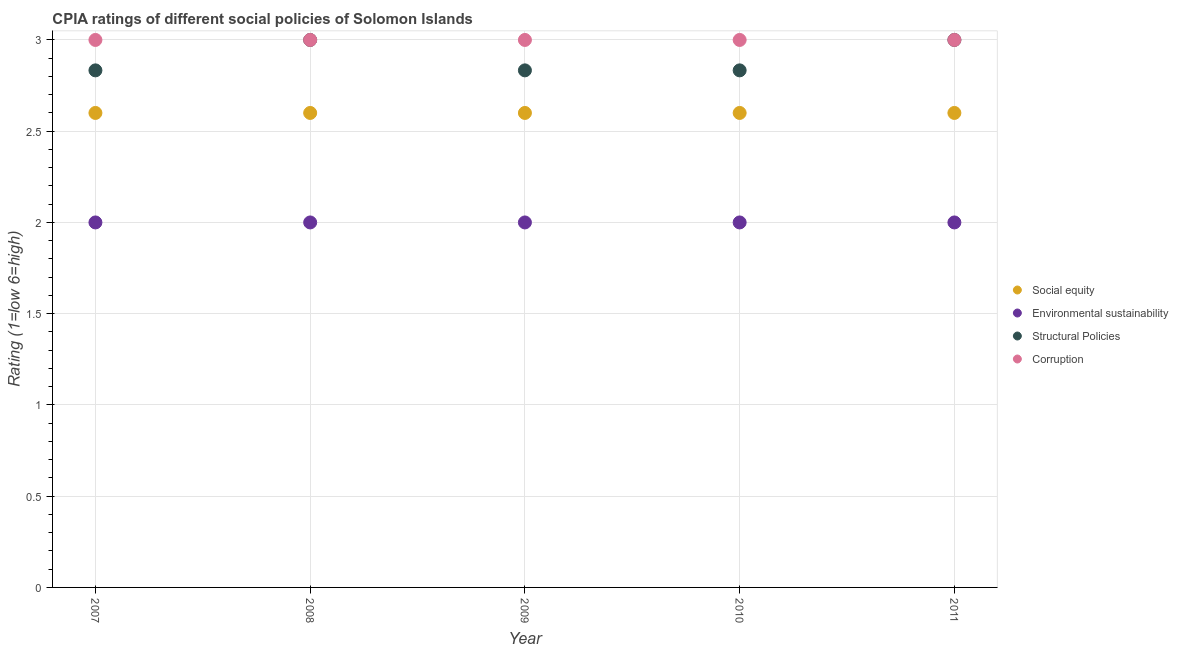What is the cpia rating of social equity in 2008?
Give a very brief answer. 2.6. Across all years, what is the maximum cpia rating of social equity?
Offer a terse response. 2.6. Across all years, what is the minimum cpia rating of corruption?
Keep it short and to the point. 3. In which year was the cpia rating of corruption maximum?
Provide a short and direct response. 2007. What is the total cpia rating of social equity in the graph?
Make the answer very short. 13. What is the difference between the cpia rating of environmental sustainability in 2008 and that in 2009?
Keep it short and to the point. 0. What is the difference between the cpia rating of structural policies in 2011 and the cpia rating of social equity in 2007?
Offer a very short reply. 0.4. In how many years, is the cpia rating of corruption greater than 1.6?
Your response must be concise. 5. What is the ratio of the cpia rating of corruption in 2009 to that in 2011?
Provide a short and direct response. 1. Is the difference between the cpia rating of environmental sustainability in 2007 and 2011 greater than the difference between the cpia rating of social equity in 2007 and 2011?
Keep it short and to the point. No. What is the difference between the highest and the lowest cpia rating of social equity?
Offer a terse response. 0. Is the sum of the cpia rating of environmental sustainability in 2008 and 2009 greater than the maximum cpia rating of social equity across all years?
Give a very brief answer. Yes. Does the cpia rating of structural policies monotonically increase over the years?
Your response must be concise. No. Is the cpia rating of social equity strictly greater than the cpia rating of environmental sustainability over the years?
Make the answer very short. Yes. Is the cpia rating of structural policies strictly less than the cpia rating of environmental sustainability over the years?
Provide a short and direct response. No. How many dotlines are there?
Your response must be concise. 4. Does the graph contain any zero values?
Make the answer very short. No. What is the title of the graph?
Offer a terse response. CPIA ratings of different social policies of Solomon Islands. Does "Austria" appear as one of the legend labels in the graph?
Ensure brevity in your answer.  No. What is the label or title of the Y-axis?
Provide a succinct answer. Rating (1=low 6=high). What is the Rating (1=low 6=high) of Environmental sustainability in 2007?
Give a very brief answer. 2. What is the Rating (1=low 6=high) in Structural Policies in 2007?
Provide a short and direct response. 2.83. What is the Rating (1=low 6=high) in Corruption in 2007?
Keep it short and to the point. 3. What is the Rating (1=low 6=high) in Structural Policies in 2008?
Your answer should be very brief. 3. What is the Rating (1=low 6=high) in Corruption in 2008?
Offer a very short reply. 3. What is the Rating (1=low 6=high) in Structural Policies in 2009?
Offer a terse response. 2.83. What is the Rating (1=low 6=high) in Social equity in 2010?
Provide a succinct answer. 2.6. What is the Rating (1=low 6=high) in Environmental sustainability in 2010?
Your response must be concise. 2. What is the Rating (1=low 6=high) of Structural Policies in 2010?
Your answer should be very brief. 2.83. What is the Rating (1=low 6=high) in Corruption in 2010?
Keep it short and to the point. 3. What is the Rating (1=low 6=high) in Social equity in 2011?
Keep it short and to the point. 2.6. What is the Rating (1=low 6=high) in Structural Policies in 2011?
Keep it short and to the point. 3. Across all years, what is the maximum Rating (1=low 6=high) of Social equity?
Your answer should be compact. 2.6. Across all years, what is the maximum Rating (1=low 6=high) in Environmental sustainability?
Make the answer very short. 2. Across all years, what is the maximum Rating (1=low 6=high) of Corruption?
Make the answer very short. 3. Across all years, what is the minimum Rating (1=low 6=high) of Structural Policies?
Ensure brevity in your answer.  2.83. Across all years, what is the minimum Rating (1=low 6=high) in Corruption?
Give a very brief answer. 3. What is the total Rating (1=low 6=high) of Social equity in the graph?
Keep it short and to the point. 13. What is the total Rating (1=low 6=high) of Environmental sustainability in the graph?
Provide a succinct answer. 10. What is the total Rating (1=low 6=high) of Corruption in the graph?
Offer a terse response. 15. What is the difference between the Rating (1=low 6=high) in Environmental sustainability in 2007 and that in 2008?
Offer a very short reply. 0. What is the difference between the Rating (1=low 6=high) of Corruption in 2007 and that in 2008?
Offer a terse response. 0. What is the difference between the Rating (1=low 6=high) in Social equity in 2007 and that in 2009?
Keep it short and to the point. 0. What is the difference between the Rating (1=low 6=high) in Environmental sustainability in 2007 and that in 2009?
Make the answer very short. 0. What is the difference between the Rating (1=low 6=high) in Structural Policies in 2007 and that in 2009?
Your answer should be compact. 0. What is the difference between the Rating (1=low 6=high) in Corruption in 2007 and that in 2009?
Offer a terse response. 0. What is the difference between the Rating (1=low 6=high) in Corruption in 2007 and that in 2010?
Give a very brief answer. 0. What is the difference between the Rating (1=low 6=high) of Structural Policies in 2007 and that in 2011?
Your answer should be very brief. -0.17. What is the difference between the Rating (1=low 6=high) of Social equity in 2008 and that in 2009?
Make the answer very short. 0. What is the difference between the Rating (1=low 6=high) of Environmental sustainability in 2008 and that in 2009?
Ensure brevity in your answer.  0. What is the difference between the Rating (1=low 6=high) of Structural Policies in 2008 and that in 2009?
Provide a succinct answer. 0.17. What is the difference between the Rating (1=low 6=high) in Corruption in 2008 and that in 2009?
Give a very brief answer. 0. What is the difference between the Rating (1=low 6=high) in Social equity in 2008 and that in 2010?
Make the answer very short. 0. What is the difference between the Rating (1=low 6=high) of Environmental sustainability in 2008 and that in 2010?
Provide a succinct answer. 0. What is the difference between the Rating (1=low 6=high) of Structural Policies in 2008 and that in 2010?
Offer a terse response. 0.17. What is the difference between the Rating (1=low 6=high) of Social equity in 2008 and that in 2011?
Make the answer very short. 0. What is the difference between the Rating (1=low 6=high) in Environmental sustainability in 2008 and that in 2011?
Your answer should be compact. 0. What is the difference between the Rating (1=low 6=high) in Corruption in 2008 and that in 2011?
Provide a short and direct response. 0. What is the difference between the Rating (1=low 6=high) in Social equity in 2009 and that in 2010?
Offer a very short reply. 0. What is the difference between the Rating (1=low 6=high) in Social equity in 2009 and that in 2011?
Offer a terse response. 0. What is the difference between the Rating (1=low 6=high) in Structural Policies in 2009 and that in 2011?
Offer a terse response. -0.17. What is the difference between the Rating (1=low 6=high) in Environmental sustainability in 2010 and that in 2011?
Provide a succinct answer. 0. What is the difference between the Rating (1=low 6=high) of Structural Policies in 2010 and that in 2011?
Your answer should be very brief. -0.17. What is the difference between the Rating (1=low 6=high) of Social equity in 2007 and the Rating (1=low 6=high) of Environmental sustainability in 2008?
Give a very brief answer. 0.6. What is the difference between the Rating (1=low 6=high) in Social equity in 2007 and the Rating (1=low 6=high) in Structural Policies in 2008?
Keep it short and to the point. -0.4. What is the difference between the Rating (1=low 6=high) in Environmental sustainability in 2007 and the Rating (1=low 6=high) in Corruption in 2008?
Offer a very short reply. -1. What is the difference between the Rating (1=low 6=high) in Structural Policies in 2007 and the Rating (1=low 6=high) in Corruption in 2008?
Ensure brevity in your answer.  -0.17. What is the difference between the Rating (1=low 6=high) in Social equity in 2007 and the Rating (1=low 6=high) in Environmental sustainability in 2009?
Your response must be concise. 0.6. What is the difference between the Rating (1=low 6=high) of Social equity in 2007 and the Rating (1=low 6=high) of Structural Policies in 2009?
Make the answer very short. -0.23. What is the difference between the Rating (1=low 6=high) of Social equity in 2007 and the Rating (1=low 6=high) of Corruption in 2009?
Your response must be concise. -0.4. What is the difference between the Rating (1=low 6=high) of Environmental sustainability in 2007 and the Rating (1=low 6=high) of Structural Policies in 2009?
Ensure brevity in your answer.  -0.83. What is the difference between the Rating (1=low 6=high) in Social equity in 2007 and the Rating (1=low 6=high) in Structural Policies in 2010?
Give a very brief answer. -0.23. What is the difference between the Rating (1=low 6=high) in Social equity in 2007 and the Rating (1=low 6=high) in Corruption in 2010?
Offer a very short reply. -0.4. What is the difference between the Rating (1=low 6=high) in Environmental sustainability in 2007 and the Rating (1=low 6=high) in Structural Policies in 2010?
Keep it short and to the point. -0.83. What is the difference between the Rating (1=low 6=high) in Environmental sustainability in 2007 and the Rating (1=low 6=high) in Corruption in 2010?
Offer a terse response. -1. What is the difference between the Rating (1=low 6=high) of Structural Policies in 2007 and the Rating (1=low 6=high) of Corruption in 2010?
Make the answer very short. -0.17. What is the difference between the Rating (1=low 6=high) in Social equity in 2007 and the Rating (1=low 6=high) in Environmental sustainability in 2011?
Your answer should be very brief. 0.6. What is the difference between the Rating (1=low 6=high) of Environmental sustainability in 2007 and the Rating (1=low 6=high) of Structural Policies in 2011?
Offer a very short reply. -1. What is the difference between the Rating (1=low 6=high) in Environmental sustainability in 2007 and the Rating (1=low 6=high) in Corruption in 2011?
Make the answer very short. -1. What is the difference between the Rating (1=low 6=high) in Structural Policies in 2007 and the Rating (1=low 6=high) in Corruption in 2011?
Your answer should be compact. -0.17. What is the difference between the Rating (1=low 6=high) of Social equity in 2008 and the Rating (1=low 6=high) of Environmental sustainability in 2009?
Your answer should be compact. 0.6. What is the difference between the Rating (1=low 6=high) in Social equity in 2008 and the Rating (1=low 6=high) in Structural Policies in 2009?
Make the answer very short. -0.23. What is the difference between the Rating (1=low 6=high) in Structural Policies in 2008 and the Rating (1=low 6=high) in Corruption in 2009?
Make the answer very short. 0. What is the difference between the Rating (1=low 6=high) of Social equity in 2008 and the Rating (1=low 6=high) of Environmental sustainability in 2010?
Provide a succinct answer. 0.6. What is the difference between the Rating (1=low 6=high) of Social equity in 2008 and the Rating (1=low 6=high) of Structural Policies in 2010?
Give a very brief answer. -0.23. What is the difference between the Rating (1=low 6=high) in Social equity in 2008 and the Rating (1=low 6=high) in Environmental sustainability in 2011?
Offer a terse response. 0.6. What is the difference between the Rating (1=low 6=high) in Social equity in 2008 and the Rating (1=low 6=high) in Structural Policies in 2011?
Make the answer very short. -0.4. What is the difference between the Rating (1=low 6=high) in Structural Policies in 2008 and the Rating (1=low 6=high) in Corruption in 2011?
Provide a succinct answer. 0. What is the difference between the Rating (1=low 6=high) of Social equity in 2009 and the Rating (1=low 6=high) of Structural Policies in 2010?
Provide a short and direct response. -0.23. What is the difference between the Rating (1=low 6=high) of Environmental sustainability in 2009 and the Rating (1=low 6=high) of Structural Policies in 2010?
Offer a very short reply. -0.83. What is the difference between the Rating (1=low 6=high) in Environmental sustainability in 2009 and the Rating (1=low 6=high) in Corruption in 2010?
Keep it short and to the point. -1. What is the difference between the Rating (1=low 6=high) in Social equity in 2010 and the Rating (1=low 6=high) in Structural Policies in 2011?
Provide a succinct answer. -0.4. In the year 2007, what is the difference between the Rating (1=low 6=high) in Social equity and Rating (1=low 6=high) in Structural Policies?
Your answer should be compact. -0.23. In the year 2007, what is the difference between the Rating (1=low 6=high) of Social equity and Rating (1=low 6=high) of Corruption?
Offer a very short reply. -0.4. In the year 2007, what is the difference between the Rating (1=low 6=high) in Environmental sustainability and Rating (1=low 6=high) in Corruption?
Ensure brevity in your answer.  -1. In the year 2008, what is the difference between the Rating (1=low 6=high) in Social equity and Rating (1=low 6=high) in Environmental sustainability?
Your response must be concise. 0.6. In the year 2008, what is the difference between the Rating (1=low 6=high) in Environmental sustainability and Rating (1=low 6=high) in Structural Policies?
Offer a very short reply. -1. In the year 2008, what is the difference between the Rating (1=low 6=high) in Environmental sustainability and Rating (1=low 6=high) in Corruption?
Provide a succinct answer. -1. In the year 2008, what is the difference between the Rating (1=low 6=high) in Structural Policies and Rating (1=low 6=high) in Corruption?
Your response must be concise. 0. In the year 2009, what is the difference between the Rating (1=low 6=high) in Social equity and Rating (1=low 6=high) in Environmental sustainability?
Provide a succinct answer. 0.6. In the year 2009, what is the difference between the Rating (1=low 6=high) in Social equity and Rating (1=low 6=high) in Structural Policies?
Keep it short and to the point. -0.23. In the year 2009, what is the difference between the Rating (1=low 6=high) in Social equity and Rating (1=low 6=high) in Corruption?
Your response must be concise. -0.4. In the year 2010, what is the difference between the Rating (1=low 6=high) of Social equity and Rating (1=low 6=high) of Structural Policies?
Make the answer very short. -0.23. In the year 2010, what is the difference between the Rating (1=low 6=high) of Social equity and Rating (1=low 6=high) of Corruption?
Your response must be concise. -0.4. In the year 2010, what is the difference between the Rating (1=low 6=high) of Environmental sustainability and Rating (1=low 6=high) of Structural Policies?
Make the answer very short. -0.83. In the year 2011, what is the difference between the Rating (1=low 6=high) in Social equity and Rating (1=low 6=high) in Environmental sustainability?
Your answer should be very brief. 0.6. In the year 2011, what is the difference between the Rating (1=low 6=high) in Social equity and Rating (1=low 6=high) in Structural Policies?
Offer a very short reply. -0.4. In the year 2011, what is the difference between the Rating (1=low 6=high) in Social equity and Rating (1=low 6=high) in Corruption?
Your answer should be very brief. -0.4. In the year 2011, what is the difference between the Rating (1=low 6=high) in Environmental sustainability and Rating (1=low 6=high) in Structural Policies?
Ensure brevity in your answer.  -1. In the year 2011, what is the difference between the Rating (1=low 6=high) of Environmental sustainability and Rating (1=low 6=high) of Corruption?
Offer a very short reply. -1. In the year 2011, what is the difference between the Rating (1=low 6=high) in Structural Policies and Rating (1=low 6=high) in Corruption?
Your answer should be very brief. 0. What is the ratio of the Rating (1=low 6=high) in Social equity in 2007 to that in 2009?
Your response must be concise. 1. What is the ratio of the Rating (1=low 6=high) in Environmental sustainability in 2007 to that in 2009?
Make the answer very short. 1. What is the ratio of the Rating (1=low 6=high) of Environmental sustainability in 2007 to that in 2010?
Offer a terse response. 1. What is the ratio of the Rating (1=low 6=high) of Structural Policies in 2007 to that in 2010?
Keep it short and to the point. 1. What is the ratio of the Rating (1=low 6=high) in Corruption in 2007 to that in 2010?
Provide a succinct answer. 1. What is the ratio of the Rating (1=low 6=high) in Social equity in 2007 to that in 2011?
Offer a terse response. 1. What is the ratio of the Rating (1=low 6=high) in Environmental sustainability in 2007 to that in 2011?
Keep it short and to the point. 1. What is the ratio of the Rating (1=low 6=high) in Structural Policies in 2008 to that in 2009?
Offer a terse response. 1.06. What is the ratio of the Rating (1=low 6=high) of Corruption in 2008 to that in 2009?
Keep it short and to the point. 1. What is the ratio of the Rating (1=low 6=high) in Environmental sustainability in 2008 to that in 2010?
Keep it short and to the point. 1. What is the ratio of the Rating (1=low 6=high) of Structural Policies in 2008 to that in 2010?
Offer a very short reply. 1.06. What is the ratio of the Rating (1=low 6=high) in Social equity in 2008 to that in 2011?
Offer a terse response. 1. What is the ratio of the Rating (1=low 6=high) in Structural Policies in 2009 to that in 2010?
Your answer should be very brief. 1. What is the ratio of the Rating (1=low 6=high) of Corruption in 2009 to that in 2011?
Offer a terse response. 1. What is the ratio of the Rating (1=low 6=high) of Social equity in 2010 to that in 2011?
Provide a short and direct response. 1. What is the ratio of the Rating (1=low 6=high) in Environmental sustainability in 2010 to that in 2011?
Provide a short and direct response. 1. What is the ratio of the Rating (1=low 6=high) in Structural Policies in 2010 to that in 2011?
Your answer should be very brief. 0.94. What is the ratio of the Rating (1=low 6=high) of Corruption in 2010 to that in 2011?
Your response must be concise. 1. 